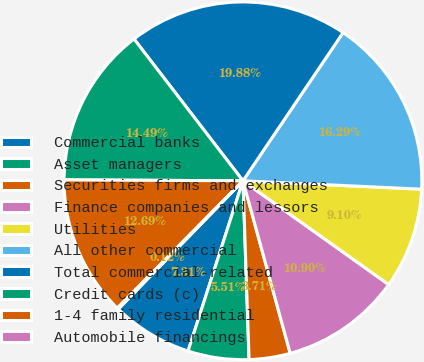<chart> <loc_0><loc_0><loc_500><loc_500><pie_chart><fcel>Commercial banks<fcel>Asset managers<fcel>Securities firms and exchanges<fcel>Finance companies and lessors<fcel>Utilities<fcel>All other commercial<fcel>Total commercial-related<fcel>Credit cards (c)<fcel>1-4 family residential<fcel>Automobile financings<nl><fcel>7.31%<fcel>5.51%<fcel>3.71%<fcel>10.9%<fcel>9.1%<fcel>16.29%<fcel>19.88%<fcel>14.49%<fcel>12.69%<fcel>0.12%<nl></chart> 